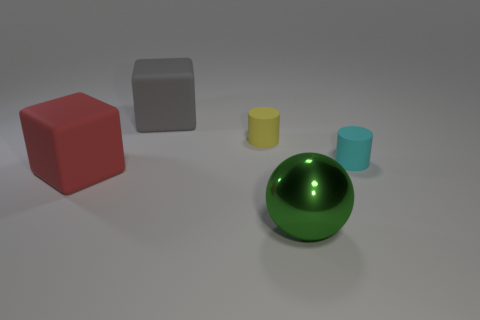There is a matte object left of the gray matte cube; is it the same shape as the small cyan thing?
Make the answer very short. No. Is the number of big red cubes on the right side of the large green metallic ball less than the number of small cyan cylinders?
Provide a succinct answer. Yes. Is there another shiny ball that has the same color as the shiny sphere?
Ensure brevity in your answer.  No. Do the red thing and the small thing to the right of the green metal sphere have the same shape?
Provide a short and direct response. No. Is there a small yellow cylinder that has the same material as the small cyan cylinder?
Offer a terse response. Yes. Is there a red thing right of the shiny thing that is to the right of the big matte object right of the red rubber cube?
Give a very brief answer. No. What number of other things are there of the same shape as the small cyan matte object?
Give a very brief answer. 1. What is the color of the large matte cube to the left of the big block behind the small object on the right side of the metal ball?
Your answer should be compact. Red. How many big rubber objects are there?
Make the answer very short. 2. How many large things are metal balls or yellow cylinders?
Ensure brevity in your answer.  1. 